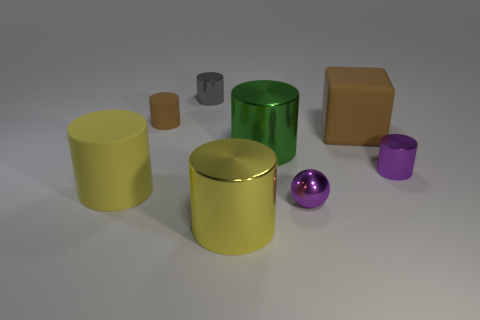Are there fewer yellow metallic cylinders that are on the left side of the small gray cylinder than purple things that are in front of the yellow metallic object?
Ensure brevity in your answer.  No. How many other objects are there of the same size as the purple metal cylinder?
Offer a very short reply. 3. Is the material of the big block the same as the large yellow cylinder to the right of the brown cylinder?
Make the answer very short. No. How many objects are green shiny things on the left side of the big brown matte thing or small matte objects that are in front of the tiny gray cylinder?
Keep it short and to the point. 2. The small matte thing has what color?
Provide a short and direct response. Brown. Is the number of tiny gray objects that are in front of the tiny gray object less than the number of small purple metallic balls?
Provide a succinct answer. Yes. Is there any other thing that has the same shape as the small gray object?
Ensure brevity in your answer.  Yes. Are there any small green objects?
Keep it short and to the point. No. Is the number of big blue metal cubes less than the number of green things?
Give a very brief answer. Yes. How many green cylinders are made of the same material as the gray cylinder?
Make the answer very short. 1. 